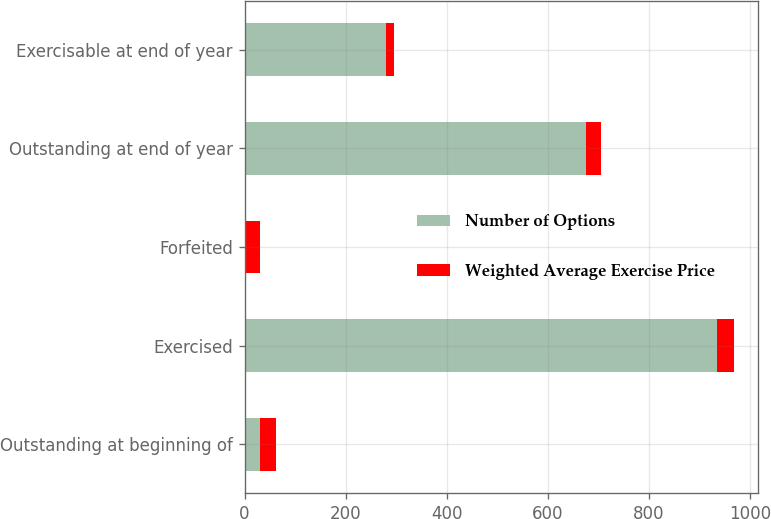Convert chart. <chart><loc_0><loc_0><loc_500><loc_500><stacked_bar_chart><ecel><fcel>Outstanding at beginning of<fcel>Exercised<fcel>Forfeited<fcel>Outstanding at end of year<fcel>Exercisable at end of year<nl><fcel>Number of Options<fcel>30.85<fcel>934<fcel>1<fcel>675<fcel>280<nl><fcel>Weighted Average Exercise Price<fcel>30.85<fcel>33.61<fcel>29.11<fcel>29.55<fcel>16.38<nl></chart> 